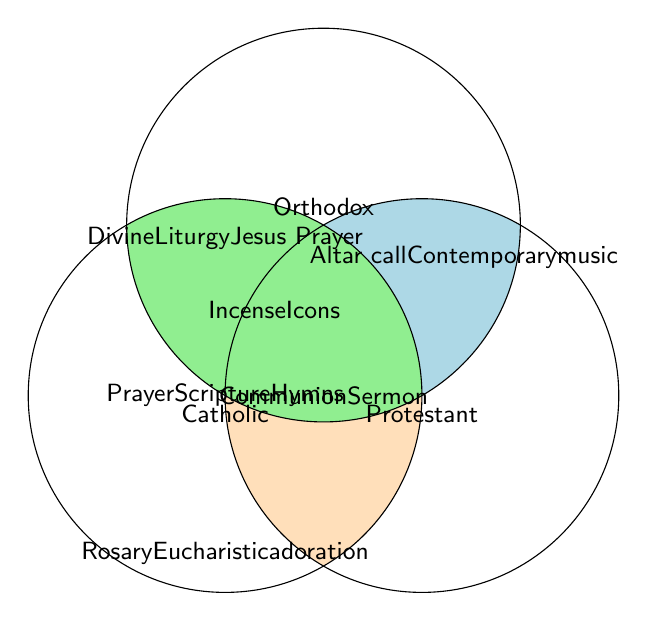What worship element is shared among Catholic, Protestant, and Orthodox traditions? The center of the Venn diagram, where all three circles overlap, lists the elements common to all three traditions. Looking at this area, we see Prayer, Scripture reading, and Singing hymns.
Answer: Prayer, Scripture reading, Singing hymns Which elements are exclusive to the Catholic tradition? In the area of the diagram only occupied by the "Catholic" circle, we find the elements unique to the Catholic tradition. Specifically, the elements Rosary and Eucharistic adoration are listed here.
Answer: Rosary, Eucharistic adoration What element is unique to the Protestant tradition? The region of the Venn diagram that only intersects with the "Protestant" circle contains elements unique to Protestantism. Looking at this section, Altar call and Contemporary worship music are listed.
Answer: Altar call, Contemporary worship music Do Catholic and Orthodox traditions share more elements than Catholic and Protestant? To determine this, compare the segments where the Catholic circle overlaps separately with the Orthodox and Protestant circles. Catholic and Orthodox share Incense and Veneration of icons (2 elements), while Catholic and Protestant share Communion and Sermon (2 elements). Thus, they share an equal number of elements with Catholicism.
Answer: No, they share an equal number of elements Which element is part of Orthodox and Protestant traditions but not Catholic? Identify the area of the Venn diagram where just the Orthodox and Protestant circles intersect without including the Catholic circle. In this case, there is no such intersection shown in the diagram, indicating no such element exists.
Answer: None How many worship elements are common between only two traditions at a time? We need to count the number of elements in the regions where each pair of circles overlap (excluding the center which includes all three). Catholic-Protestant have 2 (Communion, Sermon), Catholic-Orthodox have 2 (Incense, Veneration of icons), and there are no shared elements between just Protestant and Orthodox. Adding those gives 2 + 2 = 4 elements shared between only two traditions at a time.
Answer: 4 What unique worship element belongs to the Orthodox tradition? Locate the area only occupied by the "Orthodox" circle in the Venn diagram. This part lists Divine Liturgy and Jesus Prayer as the unique elements.
Answer: Divine Liturgy, Jesus Prayer List the elements that Catholic and Protestant traditions have in common. Look at the overlap section between the Catholic and Protestant circles in the Venn diagram. The elements located here are Communion and Sermon.
Answer: Communion, Sermon 